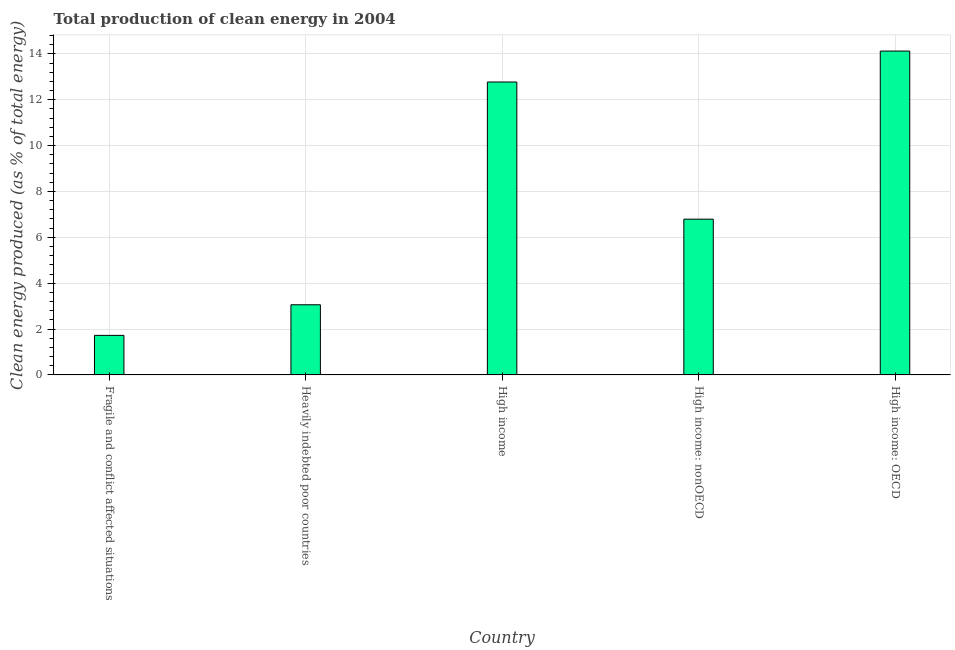Does the graph contain grids?
Your answer should be very brief. Yes. What is the title of the graph?
Your answer should be very brief. Total production of clean energy in 2004. What is the label or title of the Y-axis?
Provide a short and direct response. Clean energy produced (as % of total energy). What is the production of clean energy in High income?
Make the answer very short. 12.77. Across all countries, what is the maximum production of clean energy?
Your response must be concise. 14.12. Across all countries, what is the minimum production of clean energy?
Your answer should be compact. 1.72. In which country was the production of clean energy maximum?
Offer a very short reply. High income: OECD. In which country was the production of clean energy minimum?
Offer a very short reply. Fragile and conflict affected situations. What is the sum of the production of clean energy?
Offer a very short reply. 38.47. What is the difference between the production of clean energy in Heavily indebted poor countries and High income: OECD?
Provide a short and direct response. -11.06. What is the average production of clean energy per country?
Your response must be concise. 7.69. What is the median production of clean energy?
Keep it short and to the point. 6.79. What is the ratio of the production of clean energy in Heavily indebted poor countries to that in High income: nonOECD?
Provide a succinct answer. 0.45. Is the production of clean energy in Heavily indebted poor countries less than that in High income?
Offer a very short reply. Yes. Is the difference between the production of clean energy in High income and High income: OECD greater than the difference between any two countries?
Make the answer very short. No. What is the difference between the highest and the second highest production of clean energy?
Give a very brief answer. 1.35. What is the difference between the highest and the lowest production of clean energy?
Provide a short and direct response. 12.4. How many countries are there in the graph?
Provide a succinct answer. 5. What is the difference between two consecutive major ticks on the Y-axis?
Provide a succinct answer. 2. Are the values on the major ticks of Y-axis written in scientific E-notation?
Provide a short and direct response. No. What is the Clean energy produced (as % of total energy) of Fragile and conflict affected situations?
Your answer should be very brief. 1.72. What is the Clean energy produced (as % of total energy) of Heavily indebted poor countries?
Give a very brief answer. 3.06. What is the Clean energy produced (as % of total energy) of High income?
Your answer should be compact. 12.77. What is the Clean energy produced (as % of total energy) of High income: nonOECD?
Give a very brief answer. 6.79. What is the Clean energy produced (as % of total energy) in High income: OECD?
Make the answer very short. 14.12. What is the difference between the Clean energy produced (as % of total energy) in Fragile and conflict affected situations and Heavily indebted poor countries?
Offer a terse response. -1.33. What is the difference between the Clean energy produced (as % of total energy) in Fragile and conflict affected situations and High income?
Your answer should be very brief. -11.05. What is the difference between the Clean energy produced (as % of total energy) in Fragile and conflict affected situations and High income: nonOECD?
Your response must be concise. -5.07. What is the difference between the Clean energy produced (as % of total energy) in Fragile and conflict affected situations and High income: OECD?
Keep it short and to the point. -12.4. What is the difference between the Clean energy produced (as % of total energy) in Heavily indebted poor countries and High income?
Keep it short and to the point. -9.71. What is the difference between the Clean energy produced (as % of total energy) in Heavily indebted poor countries and High income: nonOECD?
Offer a very short reply. -3.73. What is the difference between the Clean energy produced (as % of total energy) in Heavily indebted poor countries and High income: OECD?
Provide a short and direct response. -11.06. What is the difference between the Clean energy produced (as % of total energy) in High income and High income: nonOECD?
Ensure brevity in your answer.  5.98. What is the difference between the Clean energy produced (as % of total energy) in High income and High income: OECD?
Offer a terse response. -1.35. What is the difference between the Clean energy produced (as % of total energy) in High income: nonOECD and High income: OECD?
Give a very brief answer. -7.33. What is the ratio of the Clean energy produced (as % of total energy) in Fragile and conflict affected situations to that in Heavily indebted poor countries?
Your response must be concise. 0.56. What is the ratio of the Clean energy produced (as % of total energy) in Fragile and conflict affected situations to that in High income?
Provide a succinct answer. 0.14. What is the ratio of the Clean energy produced (as % of total energy) in Fragile and conflict affected situations to that in High income: nonOECD?
Offer a terse response. 0.25. What is the ratio of the Clean energy produced (as % of total energy) in Fragile and conflict affected situations to that in High income: OECD?
Provide a succinct answer. 0.12. What is the ratio of the Clean energy produced (as % of total energy) in Heavily indebted poor countries to that in High income?
Your response must be concise. 0.24. What is the ratio of the Clean energy produced (as % of total energy) in Heavily indebted poor countries to that in High income: nonOECD?
Your answer should be very brief. 0.45. What is the ratio of the Clean energy produced (as % of total energy) in Heavily indebted poor countries to that in High income: OECD?
Make the answer very short. 0.22. What is the ratio of the Clean energy produced (as % of total energy) in High income to that in High income: nonOECD?
Ensure brevity in your answer.  1.88. What is the ratio of the Clean energy produced (as % of total energy) in High income to that in High income: OECD?
Provide a succinct answer. 0.9. What is the ratio of the Clean energy produced (as % of total energy) in High income: nonOECD to that in High income: OECD?
Make the answer very short. 0.48. 